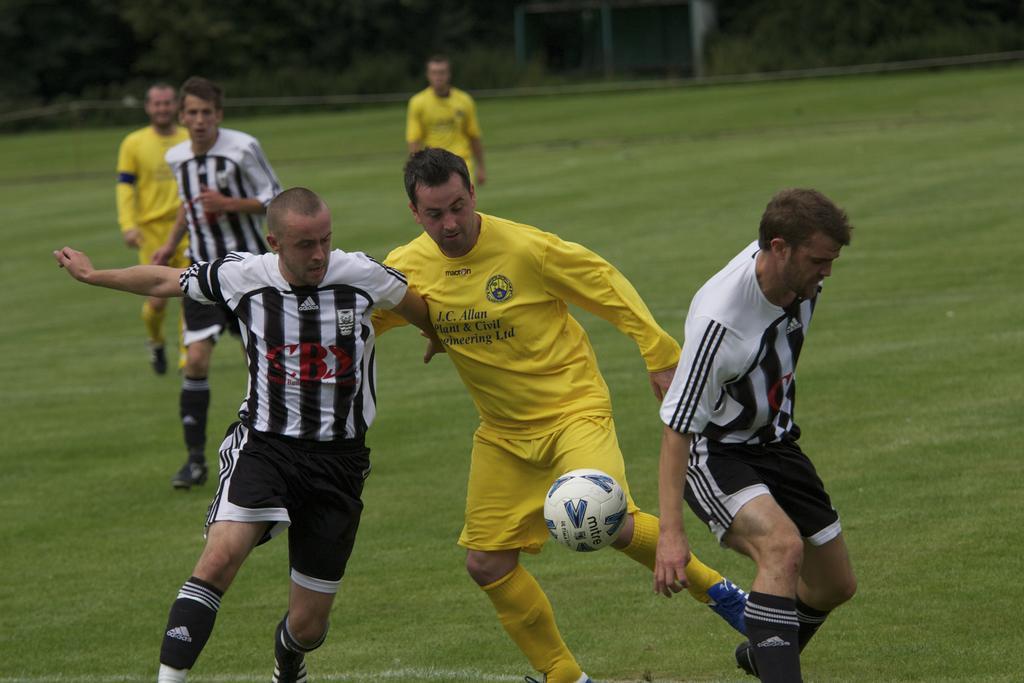Could you give a brief overview of what you see in this image? In the image we can see there are people standing on the ground and there is ball in the air. There is grass on the ground and behind there are trees. Background of the image is little blurred. 